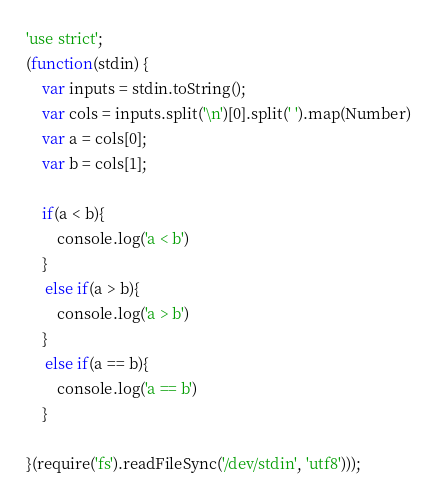<code> <loc_0><loc_0><loc_500><loc_500><_JavaScript_>'use strict';
(function(stdin) { 
	var inputs = stdin.toString();
	var cols = inputs.split('\n')[0].split(' ').map(Number)
	var a = cols[0];
	var b = cols[1];

	if(a < b){
		console.log('a < b')
	}
	 else if(a > b){
		console.log('a > b')
	}
	 else if(a == b){
		console.log('a == b')
	}

}(require('fs').readFileSync('/dev/stdin', 'utf8')));</code> 